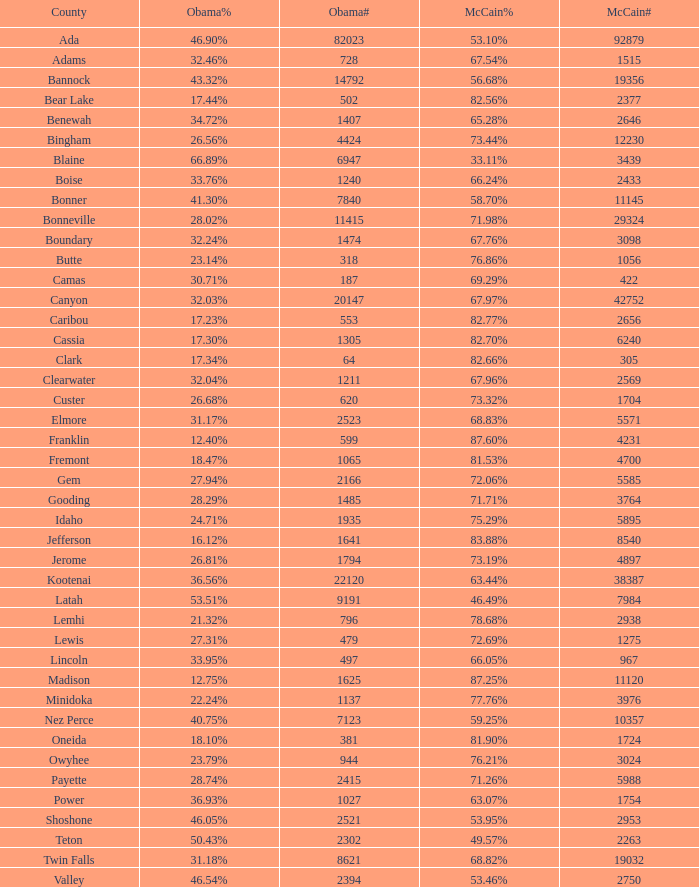34%? 1.0. 